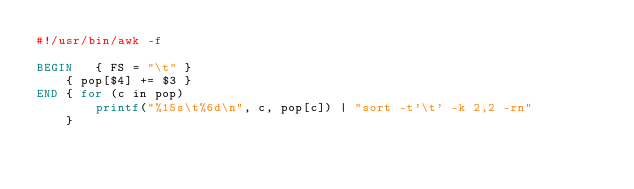<code> <loc_0><loc_0><loc_500><loc_500><_Awk_>#!/usr/bin/awk -f

BEGIN	{ FS = "\t" }
	{ pop[$4] += $3 }
END	{ for (c in pop)
		printf("%15s\t%6d\n", c, pop[c]) | "sort -t'\t' -k 2,2 -rn"
	}
</code> 